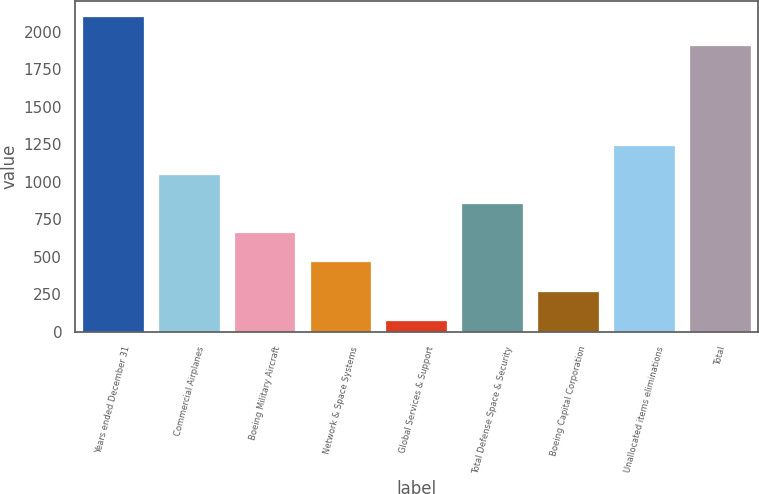Convert chart. <chart><loc_0><loc_0><loc_500><loc_500><bar_chart><fcel>Years ended December 31<fcel>Commercial Airplanes<fcel>Boeing Military Aircraft<fcel>Network & Space Systems<fcel>Global Services & Support<fcel>Total Defense Space & Security<fcel>Boeing Capital Corporation<fcel>Unallocated items eliminations<fcel>Total<nl><fcel>2099.9<fcel>1044.5<fcel>656.7<fcel>462.8<fcel>75<fcel>850.6<fcel>268.9<fcel>1238.4<fcel>1906<nl></chart> 